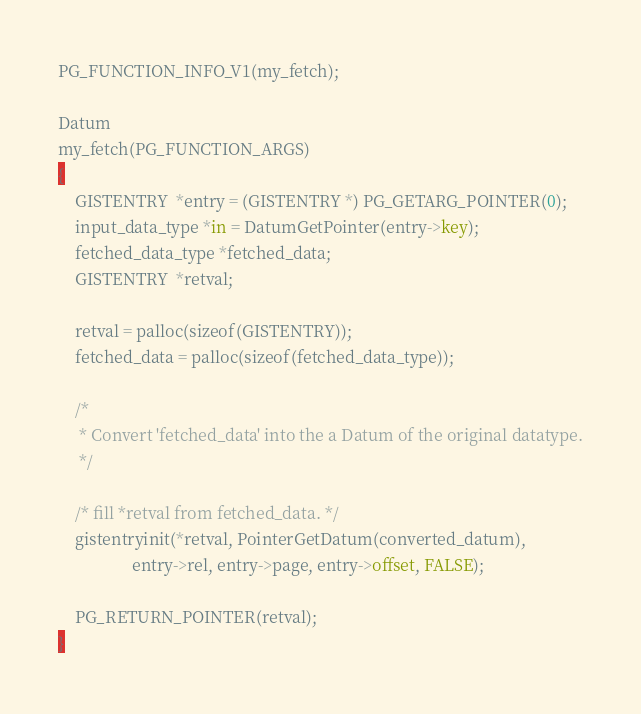Convert code to text. <code><loc_0><loc_0><loc_500><loc_500><_SQL_>PG_FUNCTION_INFO_V1(my_fetch);

Datum
my_fetch(PG_FUNCTION_ARGS)
{
    GISTENTRY  *entry = (GISTENTRY *) PG_GETARG_POINTER(0);
    input_data_type *in = DatumGetPointer(entry->key);
    fetched_data_type *fetched_data;
    GISTENTRY  *retval;

    retval = palloc(sizeof(GISTENTRY));
    fetched_data = palloc(sizeof(fetched_data_type));

    /*
     * Convert 'fetched_data' into the a Datum of the original datatype.
     */

    /* fill *retval from fetched_data. */
    gistentryinit(*retval, PointerGetDatum(converted_datum),
                  entry->rel, entry->page, entry->offset, FALSE);

    PG_RETURN_POINTER(retval);
}
</code> 